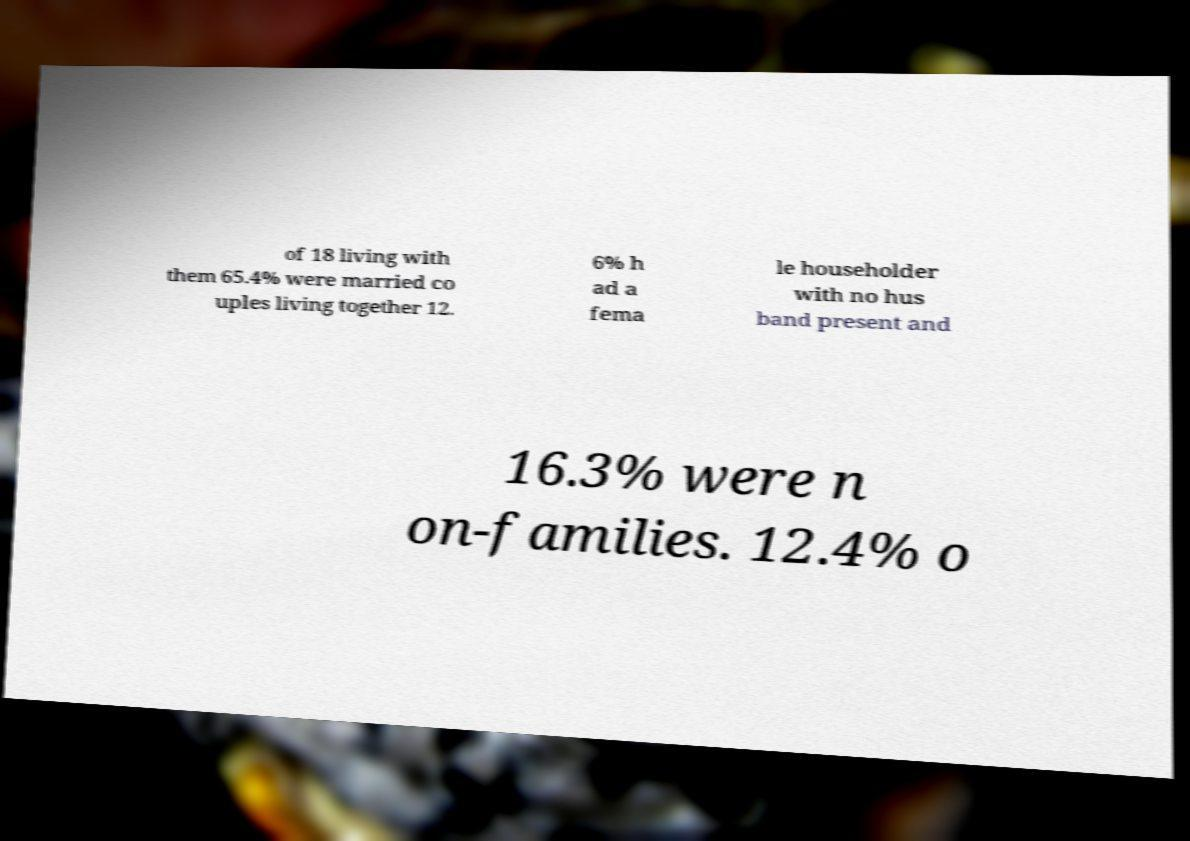Could you assist in decoding the text presented in this image and type it out clearly? of 18 living with them 65.4% were married co uples living together 12. 6% h ad a fema le householder with no hus band present and 16.3% were n on-families. 12.4% o 